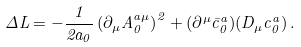Convert formula to latex. <formula><loc_0><loc_0><loc_500><loc_500>\Delta L = - \frac { 1 } { 2 a _ { 0 } } \left ( \partial _ { \mu } A _ { 0 } ^ { a \mu } \right ) ^ { 2 } + ( \partial ^ { \mu } \bar { c } _ { 0 } ^ { a } ) ( D _ { \mu } c _ { 0 } ^ { a } ) \, .</formula> 